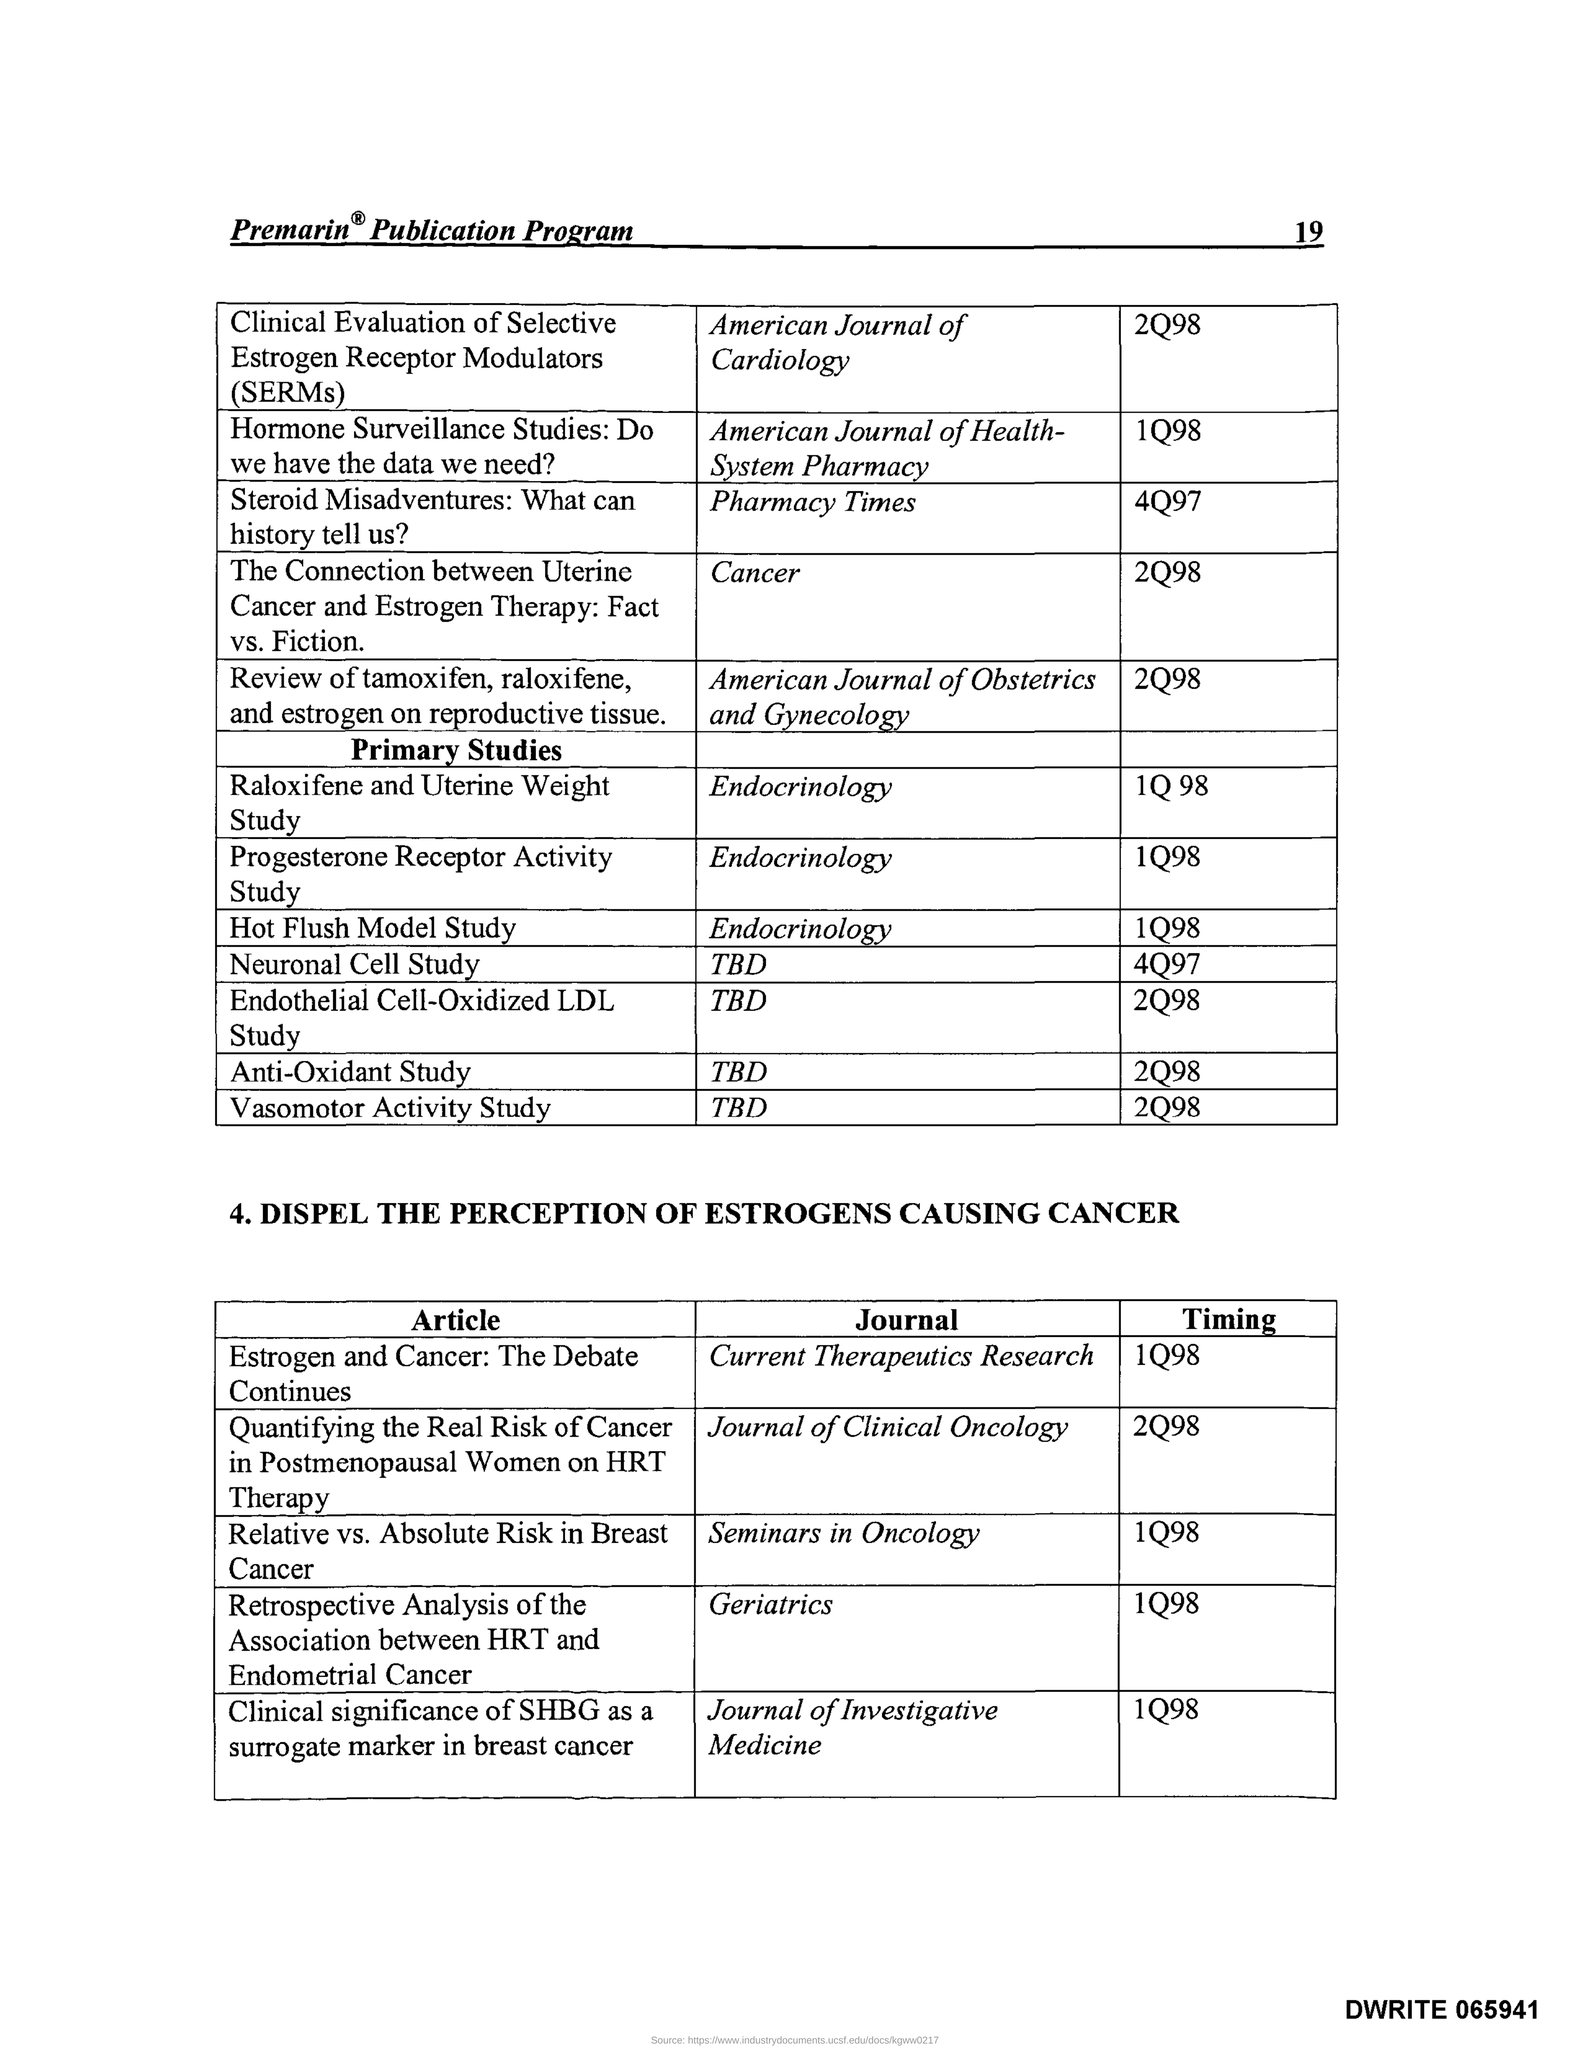Point out several critical features in this image. The article titled 'Estrogen and Cancer: The Debate Continues' in the journal 'Current Therapeutics Research' is named 'Estrogen and Cancer: The Debate Continues..'. The journal "Geriatrics" was published from 1st quarter of 1998. The journal Seminars in Oncology was published in the first quarter of 1998. The article in the journal "Seminars in Oncology" is titled "Relative vs. Absolute Risk in Breast Cancer. The page number is 19. 